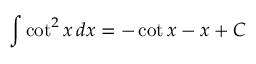Convert formula to latex. <formula><loc_0><loc_0><loc_500><loc_500>\int \cot ^ { 2 } x \, d x = - \cot x - x + C</formula> 